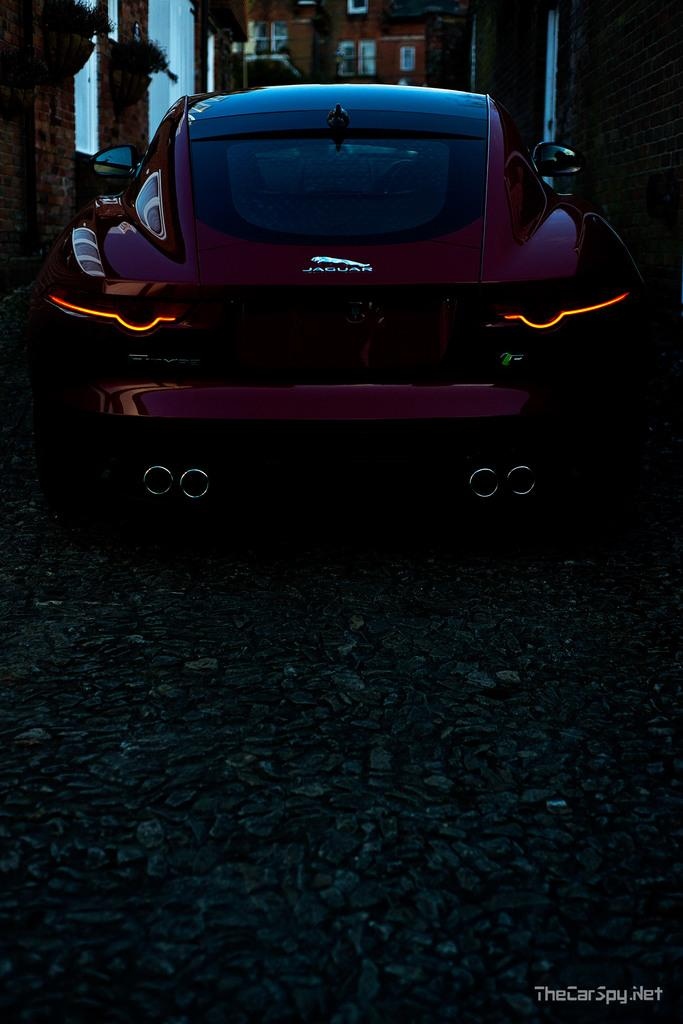What is the main subject in the image? There is a vehicle in the image. Can you describe the building that is visible in the image? There is a building with windows in the image. What type of bell can be heard ringing in the image? There is no bell present in the image, and therefore no sound can be heard. Is there a church visible in the image? The provided facts do not mention a church, so we cannot determine if one is present in the image. 